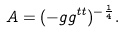Convert formula to latex. <formula><loc_0><loc_0><loc_500><loc_500>A = ( - g g ^ { t t } ) ^ { - \frac { 1 } { 4 } } .</formula> 